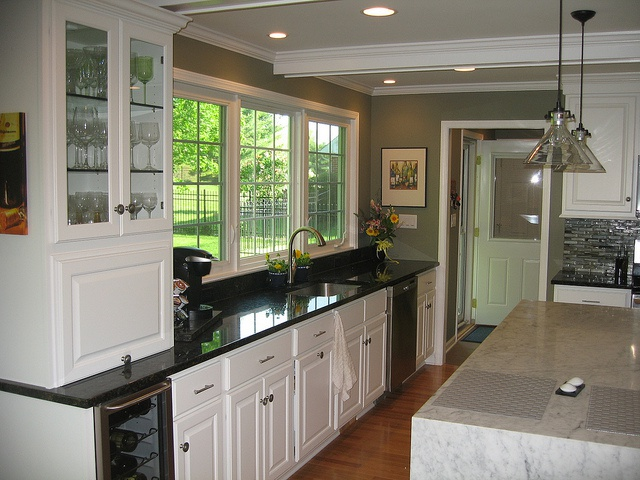Describe the objects in this image and their specific colors. I can see potted plant in black, olive, maroon, and gray tones, wine glass in black, gray, darkgreen, and darkgray tones, wine glass in black, gray, and darkgreen tones, wine glass in black, darkgreen, and gray tones, and wine glass in black, darkgray, and gray tones in this image. 